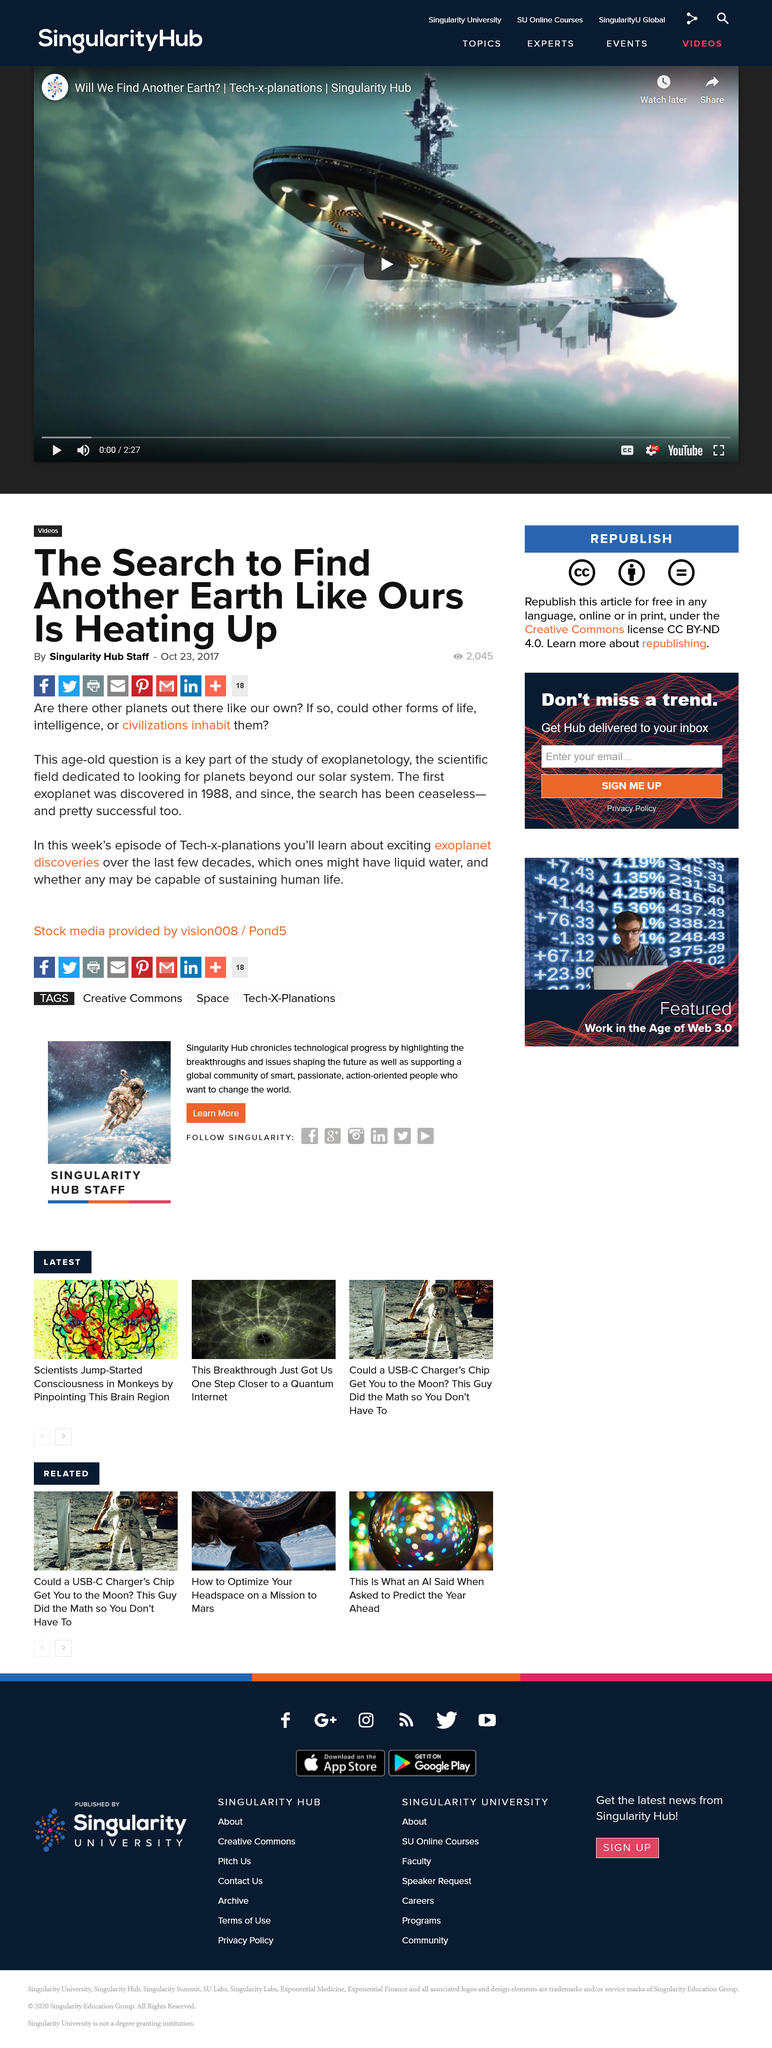Highlight a few significant elements in this photo. The discovery of the first exoplanet occurred in 1988. Exoplanetology is the scientific field dedicated to the study of planets beyond our solar system. The title of the article relates to the field of exoplanetology, which is the study of exoplanets, or planets that orbit stars outside of our solar system. 